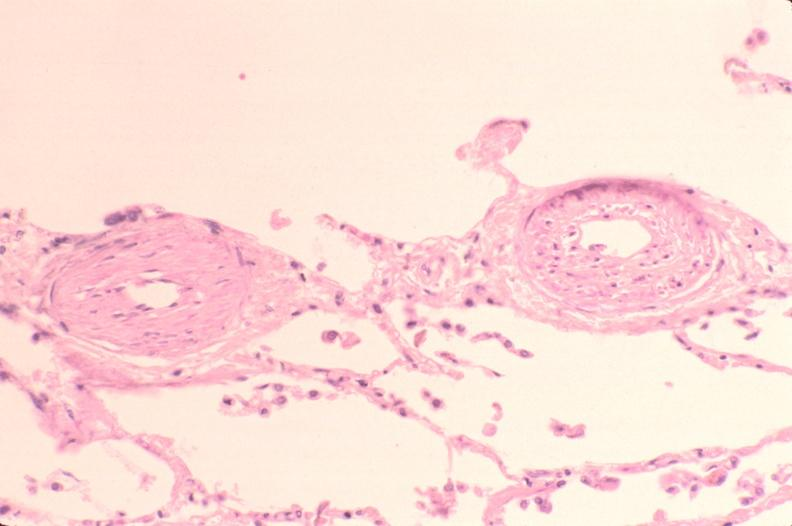does this image show lung, pulmonary artery thickening and hypertrophy in patient with pulmonary hypertension?
Answer the question using a single word or phrase. Yes 